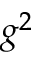Convert formula to latex. <formula><loc_0><loc_0><loc_500><loc_500>g ^ { 2 }</formula> 